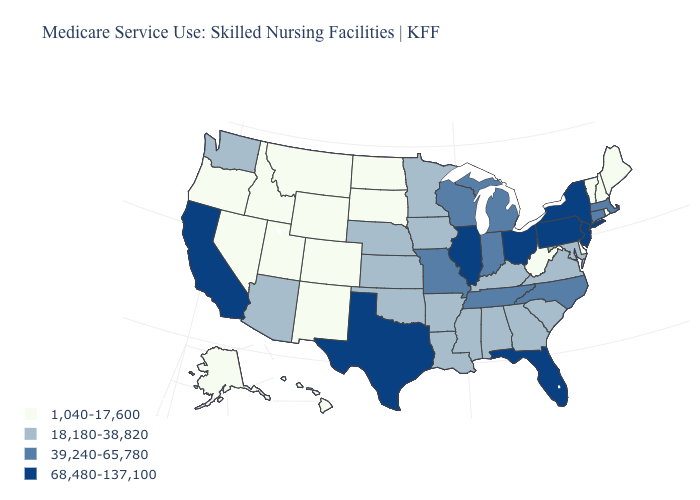Does Delaware have the lowest value in the South?
Quick response, please. Yes. What is the value of Michigan?
Write a very short answer. 39,240-65,780. Does Utah have a lower value than Oregon?
Be succinct. No. What is the value of Minnesota?
Give a very brief answer. 18,180-38,820. What is the lowest value in the Northeast?
Write a very short answer. 1,040-17,600. Among the states that border Kentucky , which have the highest value?
Write a very short answer. Illinois, Ohio. Name the states that have a value in the range 68,480-137,100?
Answer briefly. California, Florida, Illinois, New Jersey, New York, Ohio, Pennsylvania, Texas. Name the states that have a value in the range 68,480-137,100?
Write a very short answer. California, Florida, Illinois, New Jersey, New York, Ohio, Pennsylvania, Texas. Does North Dakota have the lowest value in the MidWest?
Keep it brief. Yes. Among the states that border Louisiana , does Mississippi have the lowest value?
Answer briefly. Yes. What is the highest value in states that border Indiana?
Give a very brief answer. 68,480-137,100. Does the map have missing data?
Answer briefly. No. Name the states that have a value in the range 39,240-65,780?
Be succinct. Connecticut, Indiana, Massachusetts, Michigan, Missouri, North Carolina, Tennessee, Wisconsin. Does California have the highest value in the West?
Be succinct. Yes. 